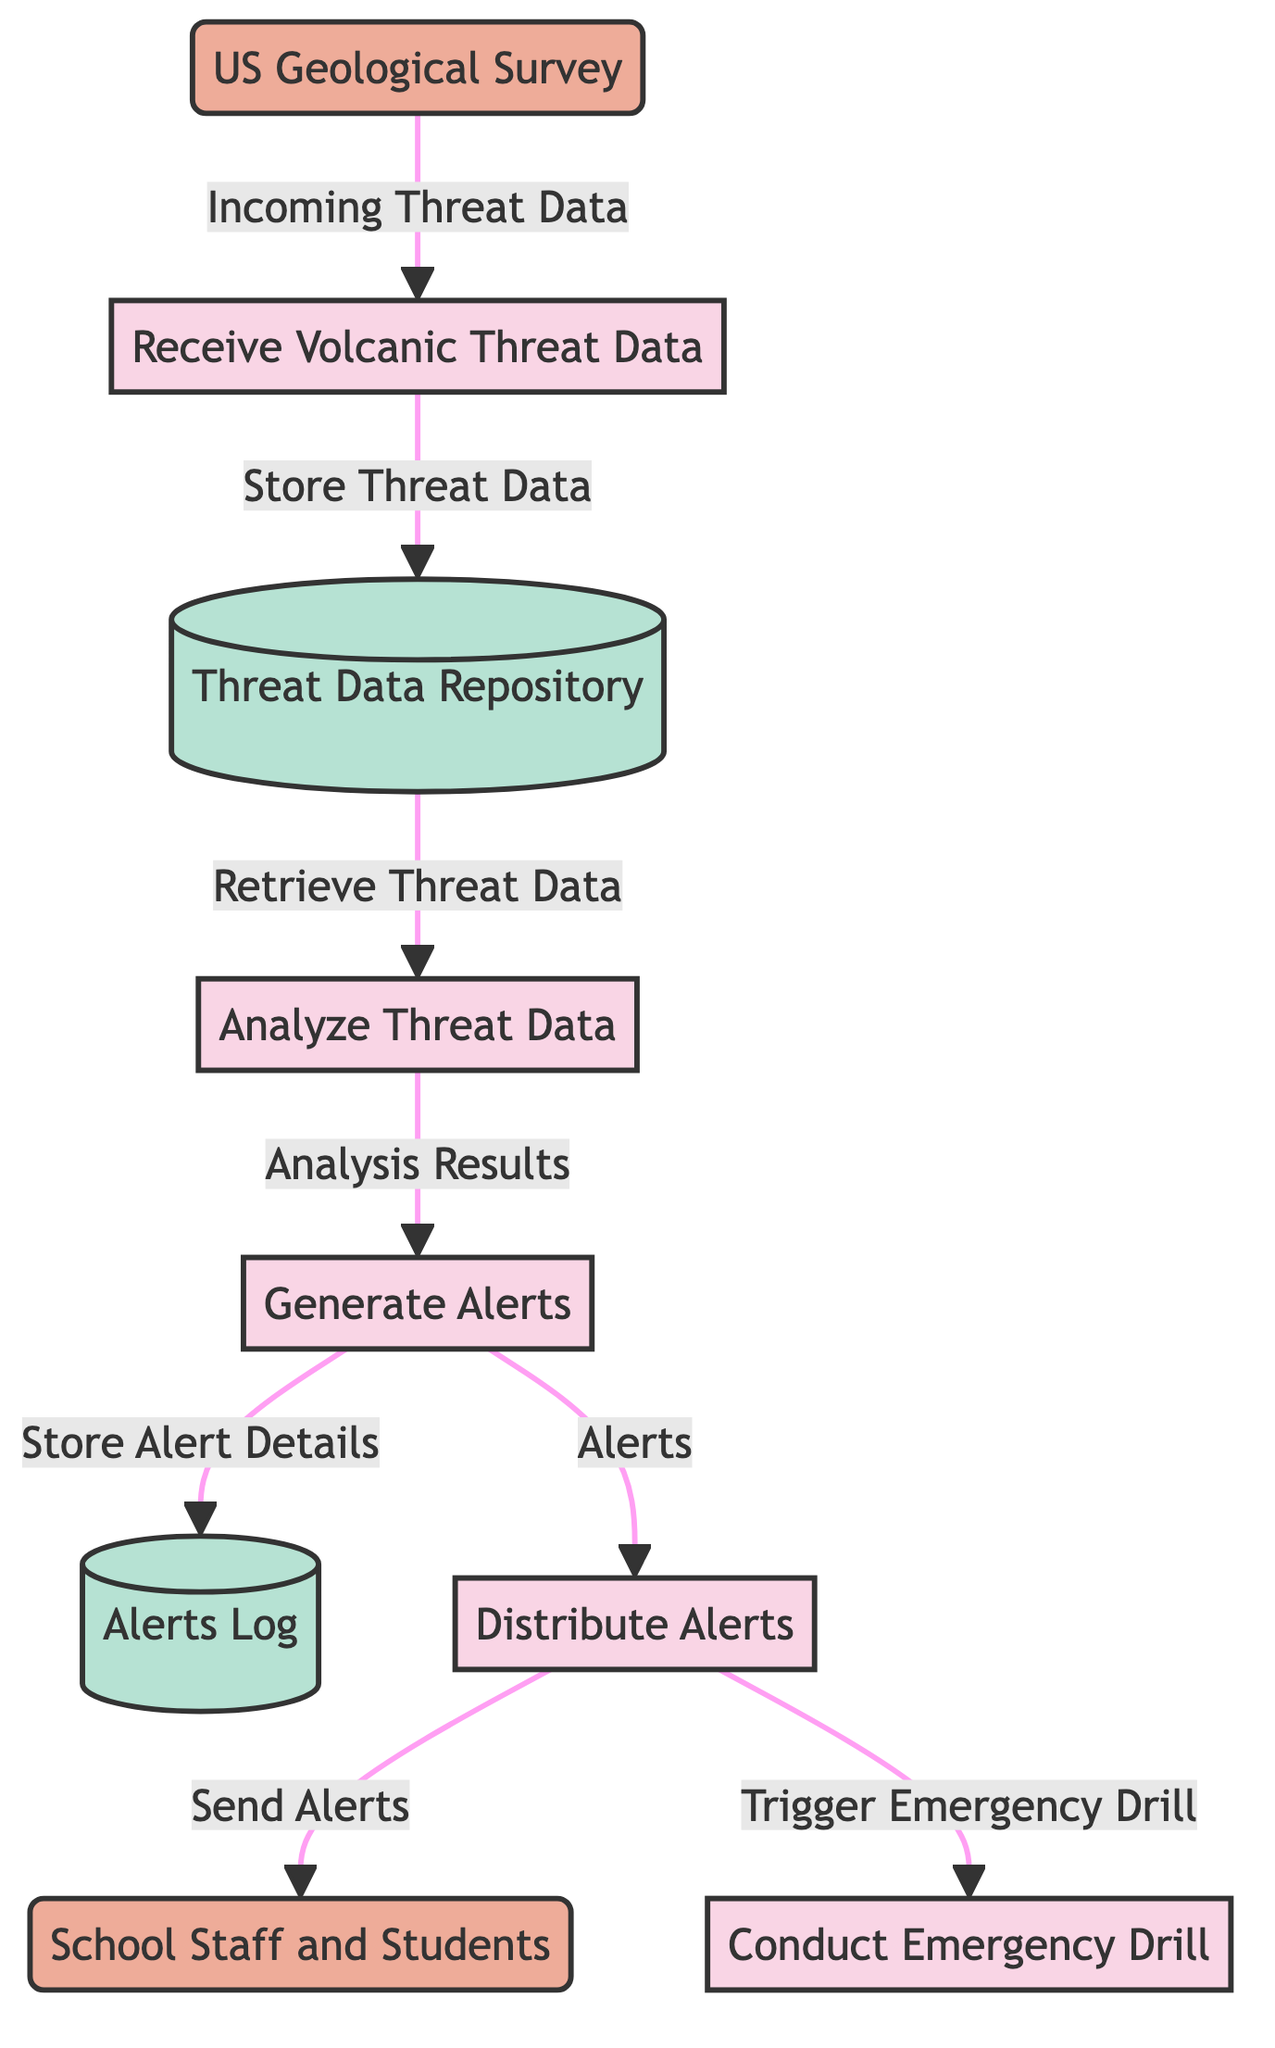What is the first process in the diagram? The first process, as indicated in the diagram, is "Receive Volcanic Threat Data." It is the starting point where data is collected from the US Geological Survey.
Answer: Receive Volcanic Threat Data How many external entities are there in the diagram? The diagram shows two external entities: the US Geological Survey and School Staff and Students. Therefore, the count is two.
Answer: 2 Which process generates alerts? The process responsible for generating alerts is "Generate Alerts," which takes the analysis results from "Analyze Threat Data."
Answer: Generate Alerts What data store contains the details of generated alerts? The store that contains the details of the generated alerts is labeled as "Alerts Log," where the alerts are recorded after generation.
Answer: Alerts Log What triggers the emergency drill based on the diagram? The process "Distribute Alerts" triggers the emergency drill, as indicated by the flow leading to the process "Conduct Emergency Drill."
Answer: Trigger Emergency Drill Explain the flow of data from the US Geological Survey to the "Analyze Threat Data" process. The flow starts with the US Geological Survey providing "Incoming Threat Data" to the "Receive Volcanic Threat Data" process. Then, after the data is received, it is stored in the "Threat Data Repository," from which it is later retrieved for analysis in the "Analyze Threat Data" process.
Answer: Incoming Threat Data What is the relationship between the "Analyze Threat Data" process and the "Generate Alerts" process? The relationship is that the "Analyze Threat Data" process provides "Analysis Results" to the "Generate Alerts" process, which uses this information to create alerts based on the assessed threat levels.
Answer: Analysis Results How many processes are there in total? The diagram includes five distinct processes which are each labeled and connected, indicating their function in the data flow framework.
Answer: 5 Where does the "Store Threat Data" flow to after the "Receive Volcanic Threat Data"? The "Store Threat Data" flow goes from the "Receive Volcanic Threat Data" process to the "Threat Data Repository," where the collected threat data is stored.
Answer: Threat Data Repository 